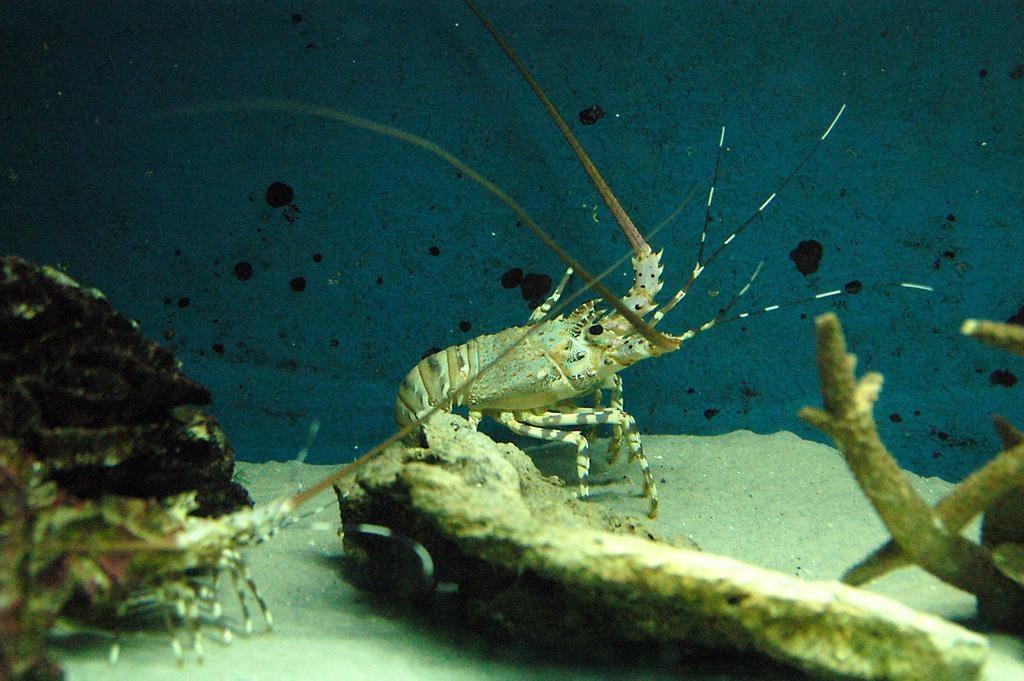What type of seafood can be seen in the image? There are lobsters in the image. Where are the lobsters located? The lobsters are under the water. What color is the light emitted by the lobsters in the image? There is no light emitted by the lobsters in the image, as they are underwater and not producing any light. 